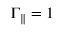Convert formula to latex. <formula><loc_0><loc_0><loc_500><loc_500>\Gamma _ { \| } = 1</formula> 